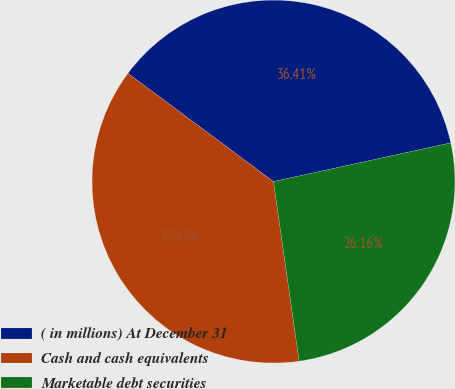Convert chart to OTSL. <chart><loc_0><loc_0><loc_500><loc_500><pie_chart><fcel>( in millions) At December 31<fcel>Cash and cash equivalents<fcel>Marketable debt securities<nl><fcel>36.41%<fcel>37.43%<fcel>26.16%<nl></chart> 